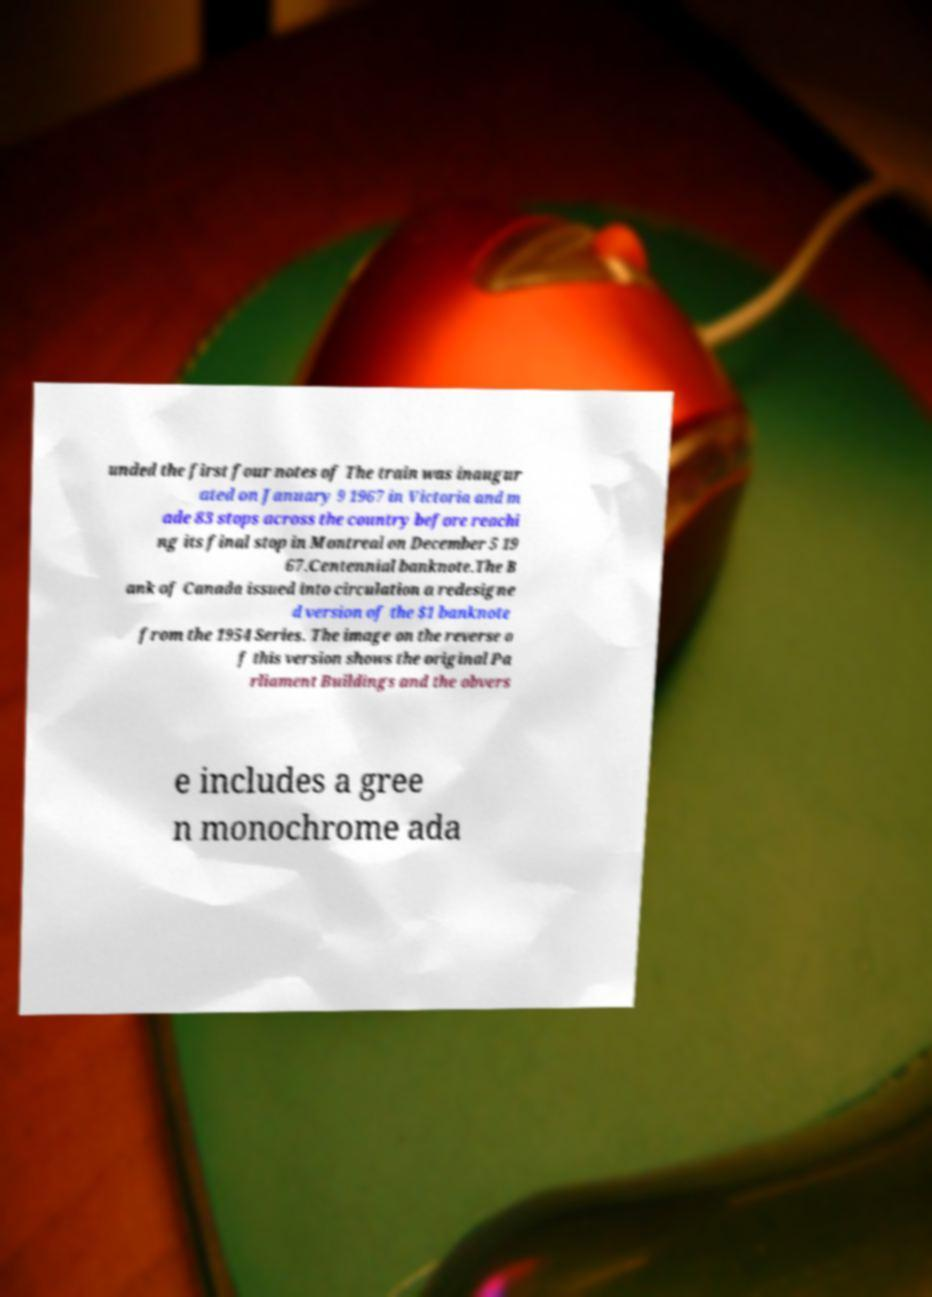I need the written content from this picture converted into text. Can you do that? unded the first four notes of The train was inaugur ated on January 9 1967 in Victoria and m ade 83 stops across the country before reachi ng its final stop in Montreal on December 5 19 67.Centennial banknote.The B ank of Canada issued into circulation a redesigne d version of the $1 banknote from the 1954 Series. The image on the reverse o f this version shows the original Pa rliament Buildings and the obvers e includes a gree n monochrome ada 